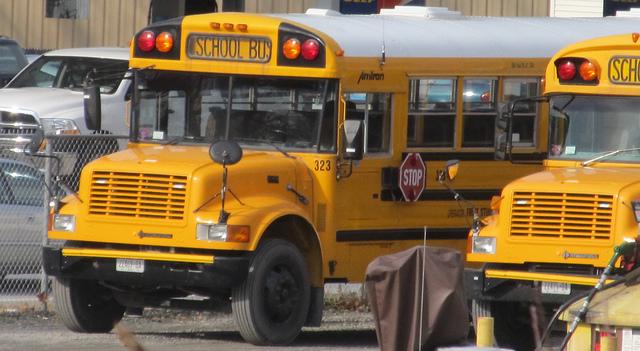What color are the buses?
Quick response, please. Yellow. Why is there a stop sign attached to the bus?
Quick response, please. Protect children. What is the first busses number?
Give a very brief answer. 323. 